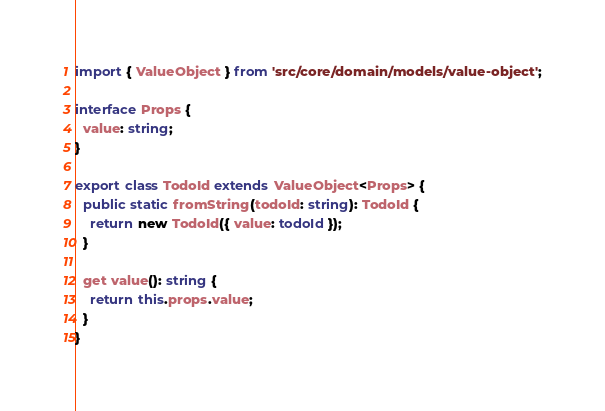<code> <loc_0><loc_0><loc_500><loc_500><_TypeScript_>
import { ValueObject } from 'src/core/domain/models/value-object';

interface Props {
  value: string;
}

export class TodoId extends ValueObject<Props> {
  public static fromString(todoId: string): TodoId {
    return new TodoId({ value: todoId });
  }

  get value(): string {
    return this.props.value;
  }
}</code> 